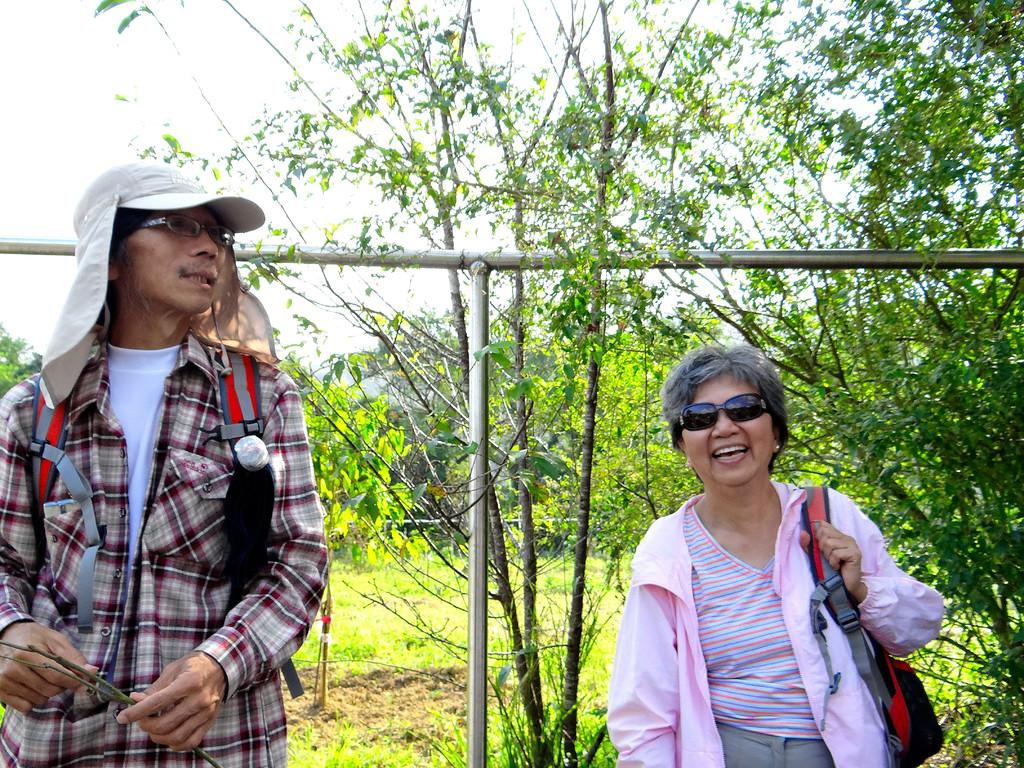How many people are in the image? There are two people in the image. What are the people doing in the image? The people are carrying bags and smiling. What type of terrain is visible in the image? There is grass visible in the image. What can be seen in the background of the image? There are trees, poles, and the sky visible in the background of the image. What type of floor can be seen in the image? There is no floor visible in the image; it appears to be an outdoor scene with grass and trees. What is the people's desire in the image? There is no information about the people's desires in the image; we can only observe their actions and expressions. 